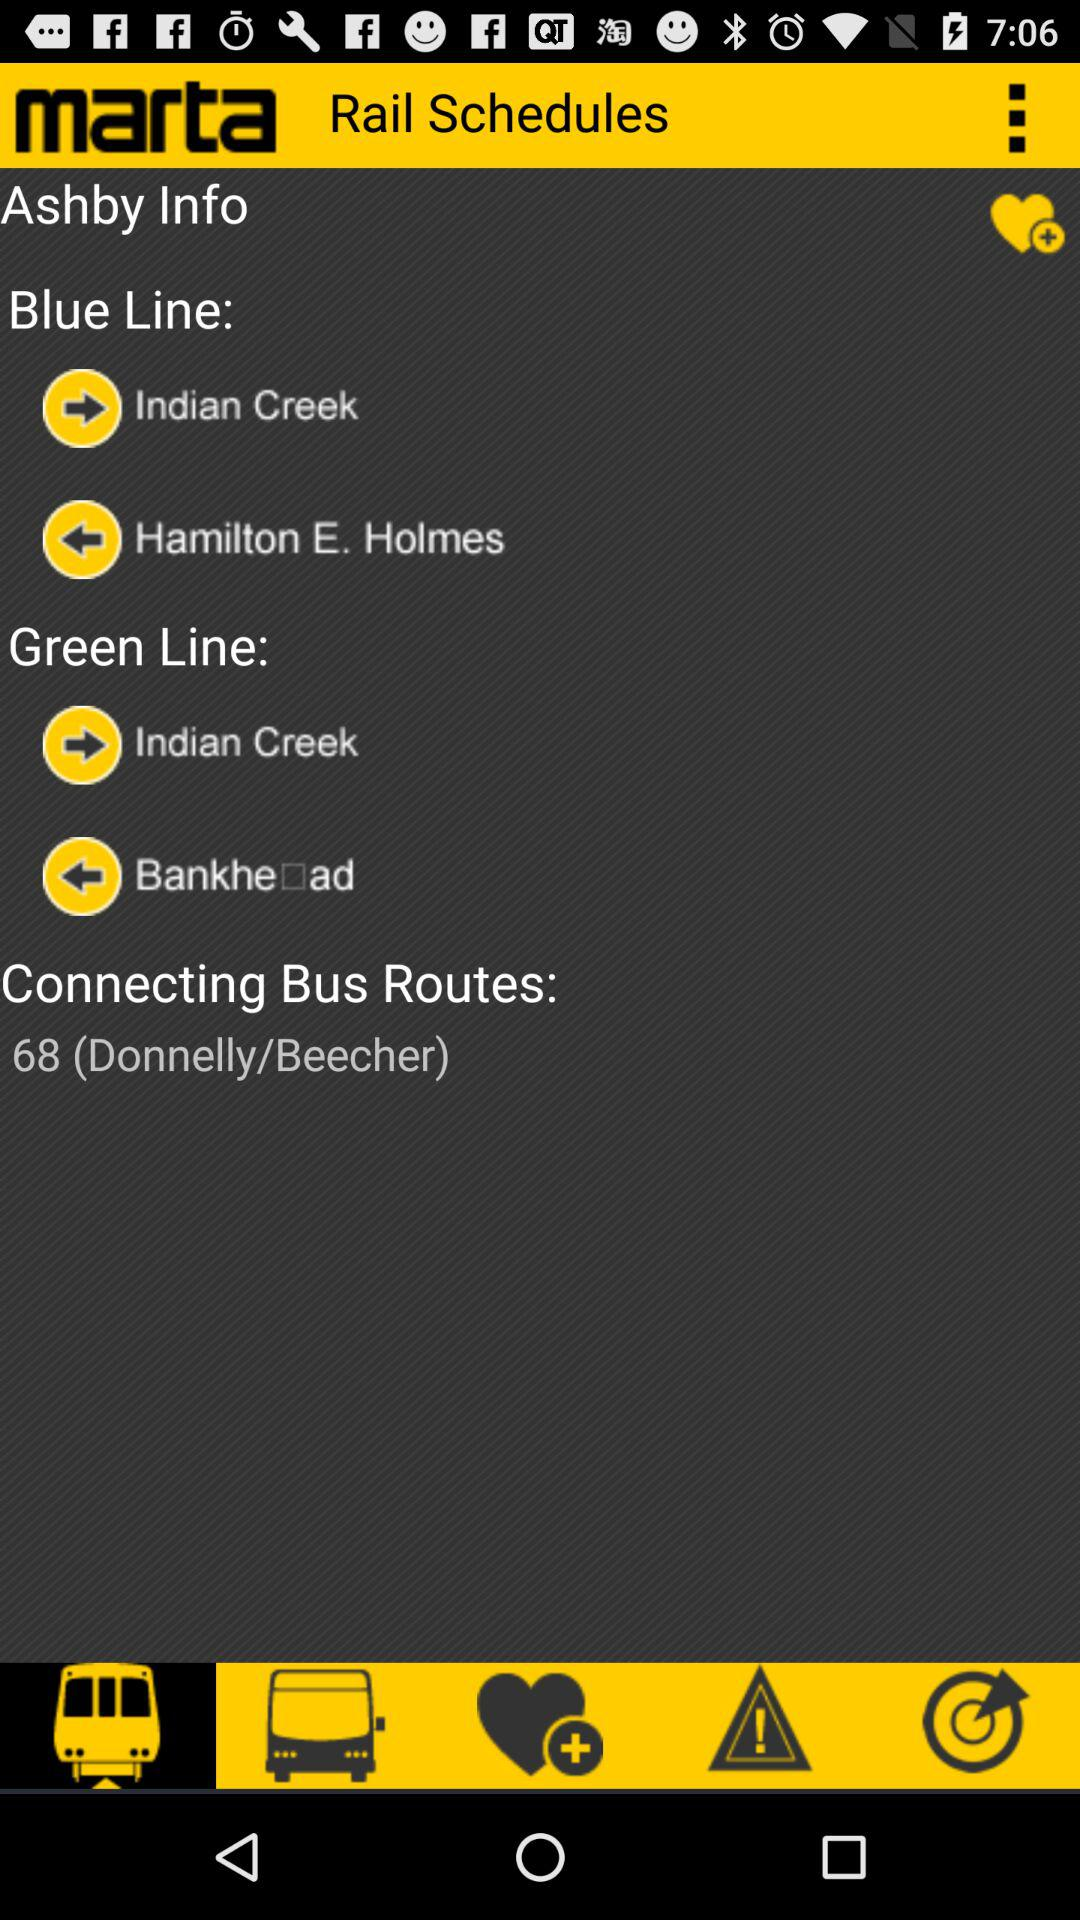Which tab has been selected? The tab that has been selected is "Rapid Transit". 